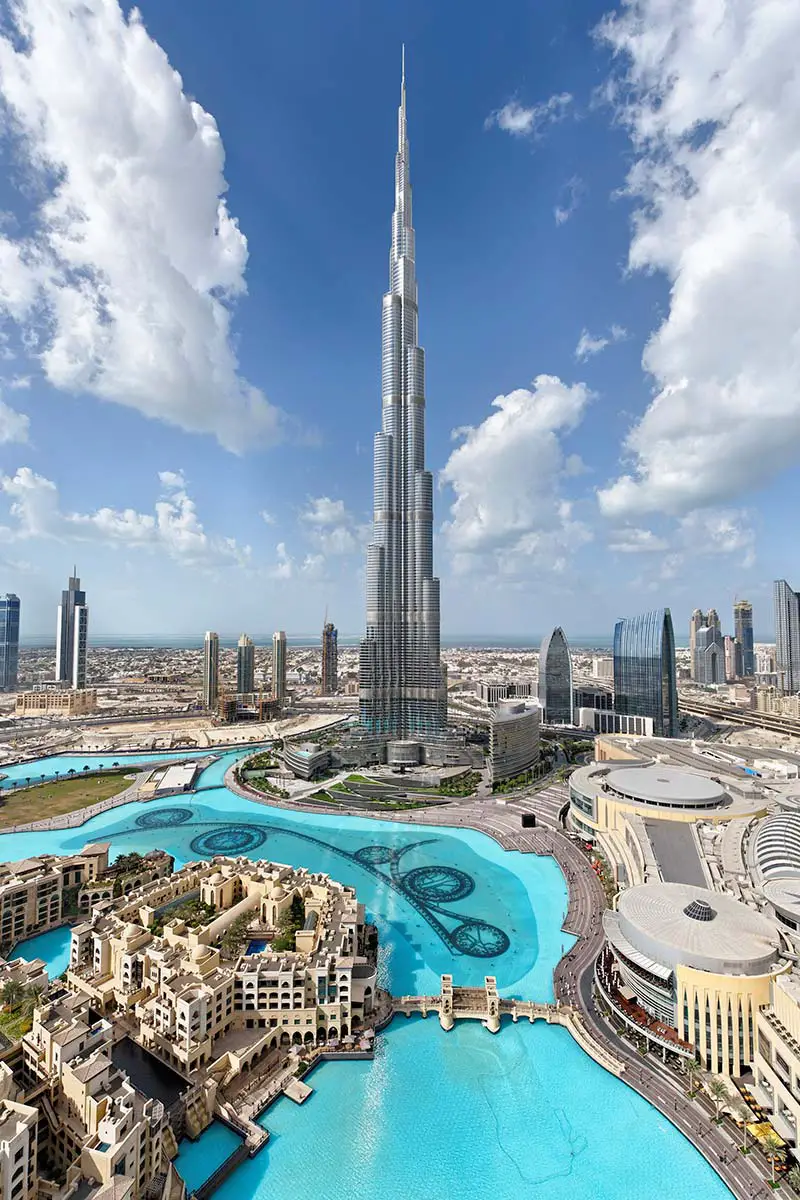Can you describe the impact of light and shadow in this image? The image effectively captures the interplay of light and shadow, which adds depth and dimension to the scene. The sunlight enhances the reflective surfaces of the Burj Khalifa and the surrounding buildings, creating a vibrant contrast with the shaded areas. This play of light also highlights the textured facades and the intricate patterns within the water, resulting in an image that is rich in detail and captivating to the viewer. What does this image reveal about the urban layout of Dubai? This image showcases Dubai's urban planning with wide, sweeping roads that facilitate movement throughout the city. The structured layout around the Burj Khalifa, with radial and concentric patterns, suggests careful city planning that prioritizes accessibility and aesthetics. High-rise buildings are strategically placed, creating an urban space that is both functional and visually appealing, indicative of Dubai's modernity and forward-thinking approach to urban development. 